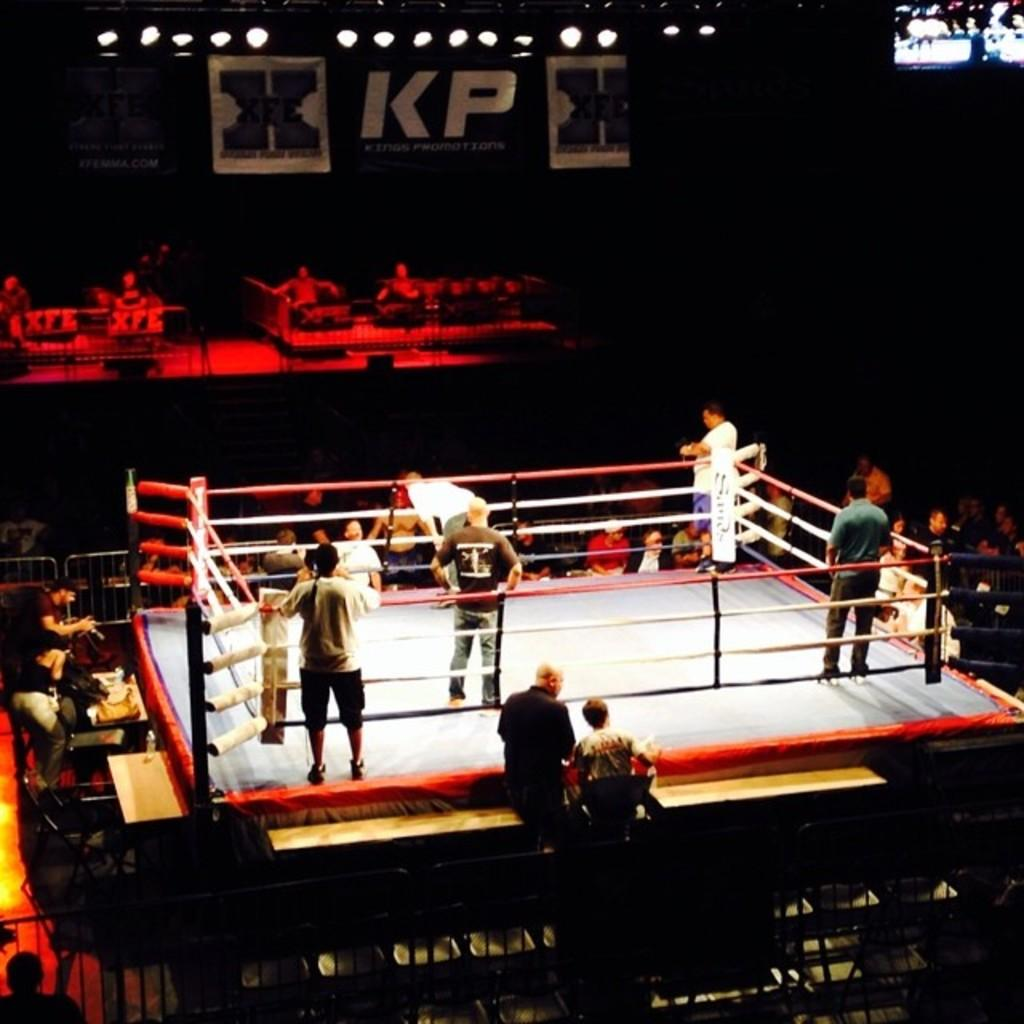Provide a one-sentence caption for the provided image. People standing in the ring of a KP Promotions boxing event. 